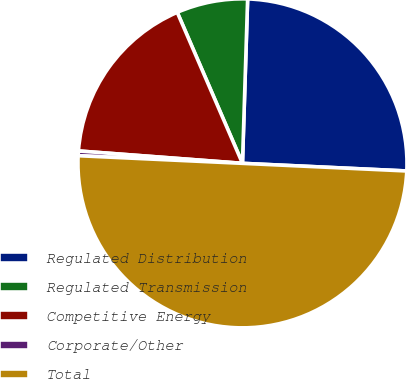<chart> <loc_0><loc_0><loc_500><loc_500><pie_chart><fcel>Regulated Distribution<fcel>Regulated Transmission<fcel>Competitive Energy<fcel>Corporate/Other<fcel>Total<nl><fcel>25.24%<fcel>6.99%<fcel>17.31%<fcel>0.46%<fcel>50.0%<nl></chart> 